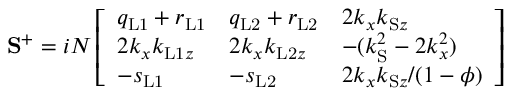<formula> <loc_0><loc_0><loc_500><loc_500>S ^ { + } = i N \left [ \begin{array} { l l l } { q _ { L 1 } + r _ { L 1 } } & { q _ { L 2 } + r _ { L 2 } } & { 2 k _ { x } k _ { S z } } \\ { 2 k _ { x } k _ { L 1 z } } & { 2 k _ { x } k _ { L 2 z } } & { - ( k _ { S } ^ { 2 } - 2 k _ { x } ^ { 2 } ) } \\ { - s _ { L 1 } } & { - s _ { L 2 } } & { 2 k _ { x } k _ { S z } / ( 1 - \phi ) } \end{array} \right ]</formula> 